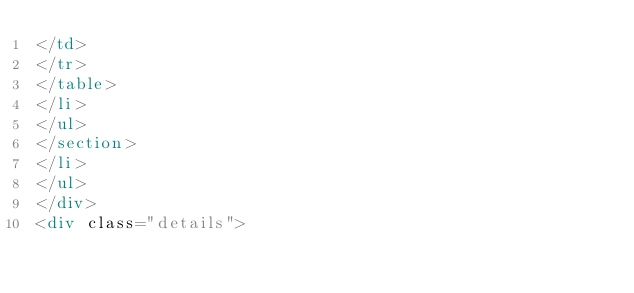<code> <loc_0><loc_0><loc_500><loc_500><_HTML_></td>
</tr>
</table>
</li>
</ul>
</section>
</li>
</ul>
</div>
<div class="details"></code> 